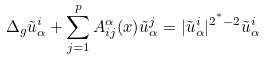Convert formula to latex. <formula><loc_0><loc_0><loc_500><loc_500>\Delta _ { g } \tilde { u } _ { \alpha } ^ { i } + \sum _ { j = 1 } ^ { p } A ^ { \alpha } _ { i j } ( x ) \tilde { u } _ { \alpha } ^ { j } = | \tilde { u } _ { \alpha } ^ { i } | ^ { 2 ^ { ^ { * } } - 2 } \tilde { u } _ { \alpha } ^ { i }</formula> 